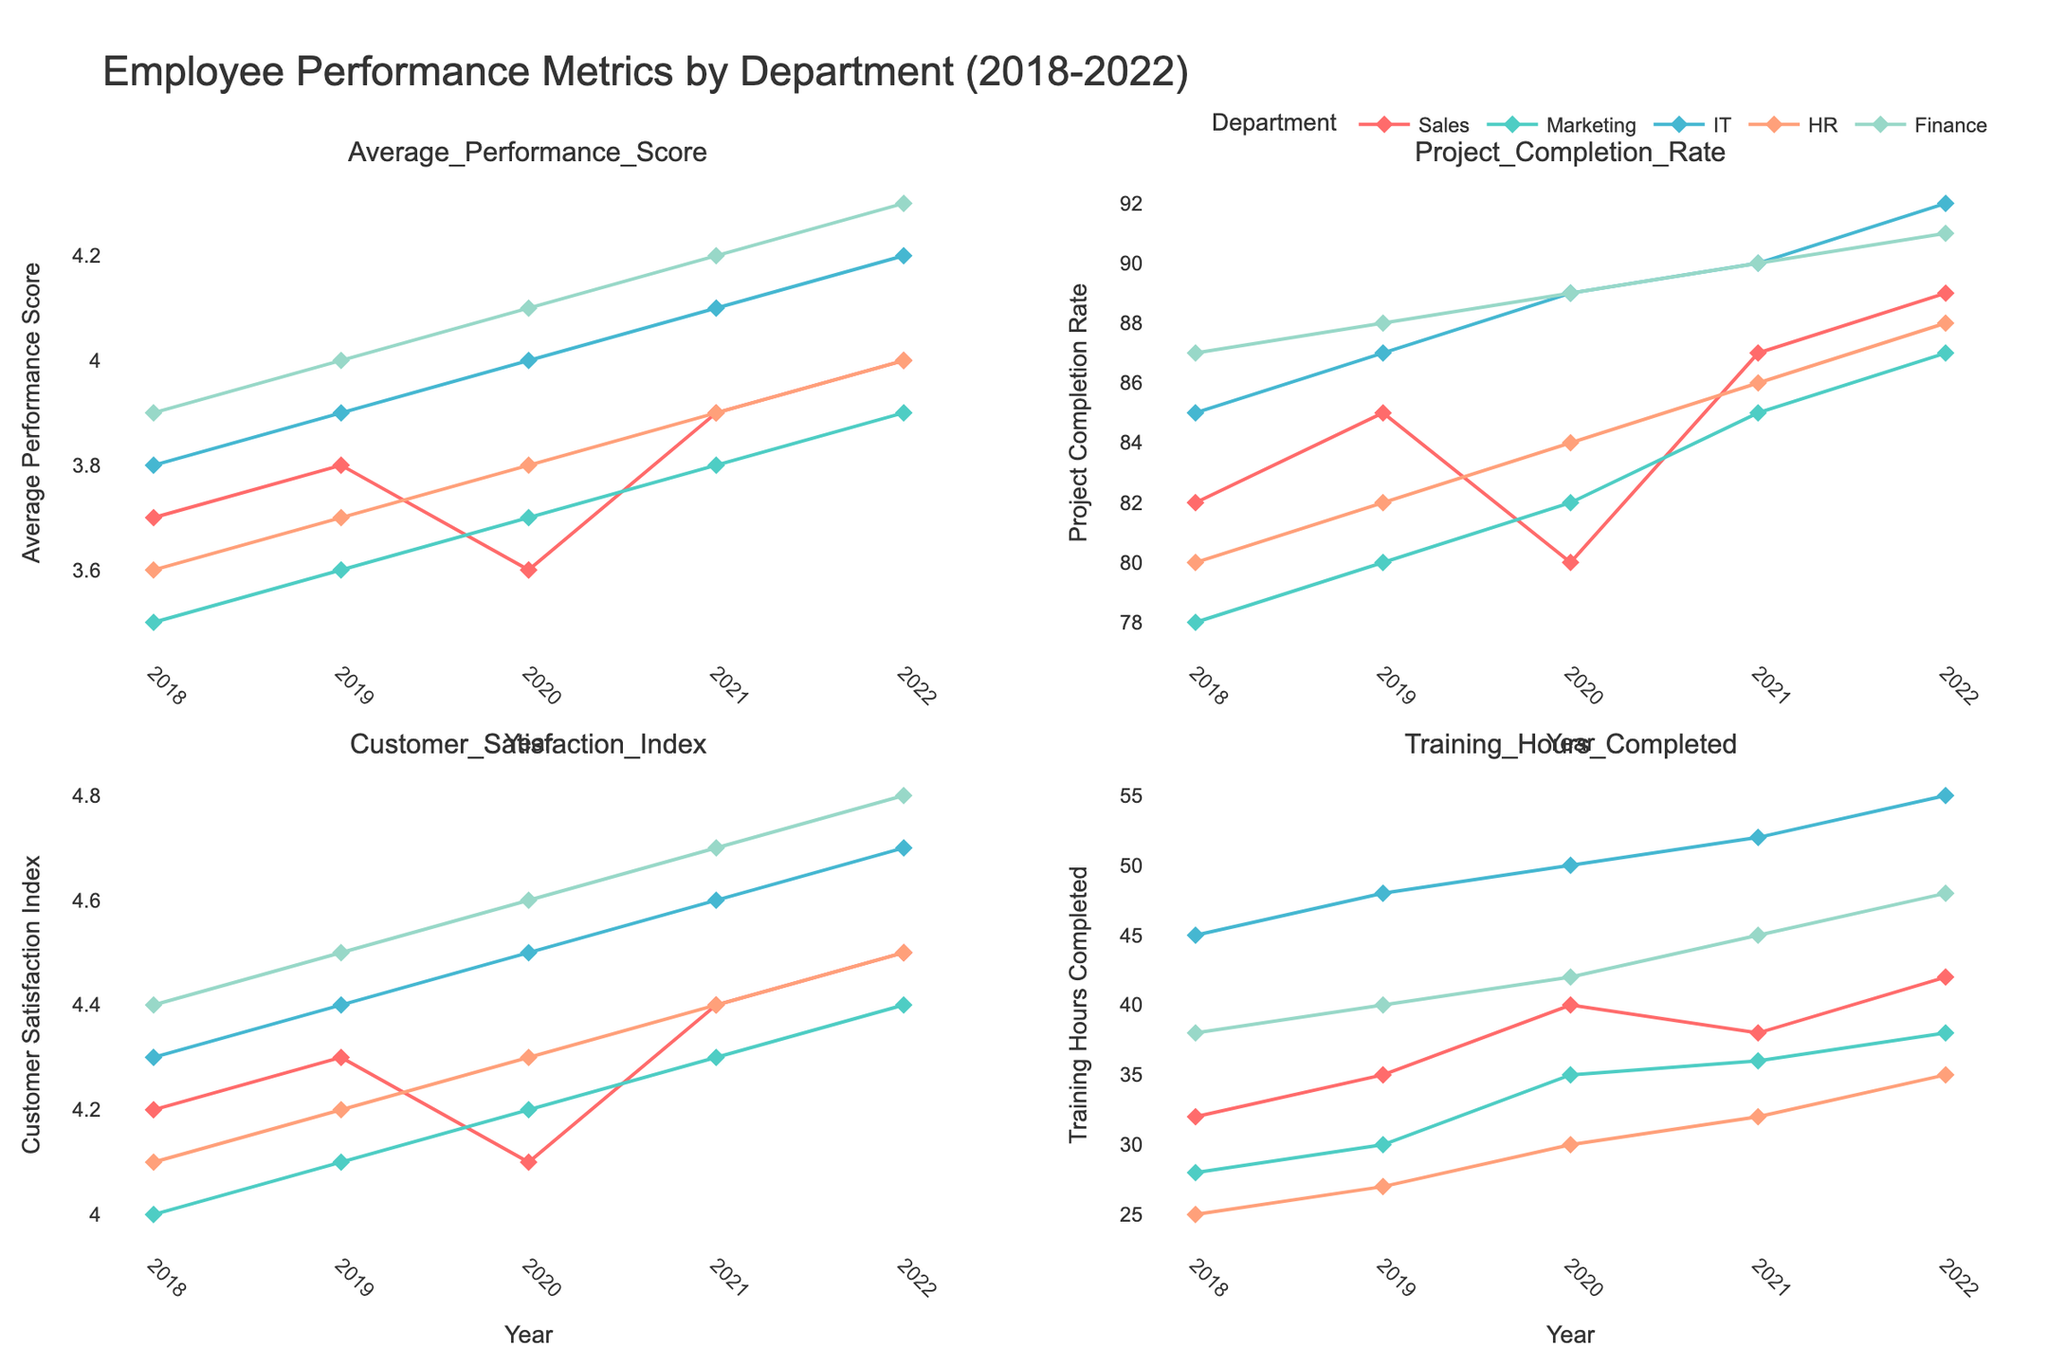Which department had the highest Average Performance Score in 2022? By looking at the subplot for Average Performance Score, we can see that the highest score in 2022 is in Finance with a score of 4.3
Answer: Finance What is the trend in Customer Satisfaction Index for the IT department from 2018 to 2022? Observing the Customer Satisfaction Index subplot, the line representing IT shows a steady increase from 4.3 in 2018 to 4.7 in 2022
Answer: Steady increase What is the difference in Project Completion Rate between HR and Sales in 2022? In the Project Completion Rate subplot, HR has a rate of 88% and Sales has a rate of 89% in 2022. The difference is 89% - 88% = 1%
Answer: 1% Which department had the greatest increase in Training Hours Completed from 2018 to 2022? Comparing the lines in the Training Hours Completed subplot, IT shows the greatest increase from 45 hours in 2018 to 55 hours in 2022, an increase of 10 hours
Answer: IT How did the Employee Count in the Marketing department change from 2018 to 2022? Looking at the subplot with metrics for Marketing, the Employee Count increased from 30 in 2018 to 40 in 2022
Answer: Increased Which metric shows the most consistent performance across all departments from 2018 to 2022? Evaluating all subplots, the Average Performance Score shows relatively smooth and consistent lines for all departments over the years
Answer: Average Performance Score Between Sales and Finance, which department has seen a higher Customer Satisfaction Index in the past five years? The Customer Satisfaction Index subplot indicates that Finance consistently has a higher index than Sales from 2018 to 2022
Answer: Finance What is the average Project Completion Rate for the IT department over the 5 years? The Project Completion Rates for IT from 2018 to 2022 are 85, 87, 89, 90, and 92. The average is (85+87+89+90+92) / 5 = 88.6
Answer: 88.6 Which year had the lowest Average Performance Score for the Sales department? The subplot for Average Performance Score shows that 2020 had the lowest score for Sales at 3.6
Answer: 2020 How does the Training Hours Completed in HR compare to IT in 2022? In the Training Hours Completed subplot, HR has 35 hours, while IT has 55 hours in 2022. HR has fewer training hours compared to IT
Answer: Fewer 